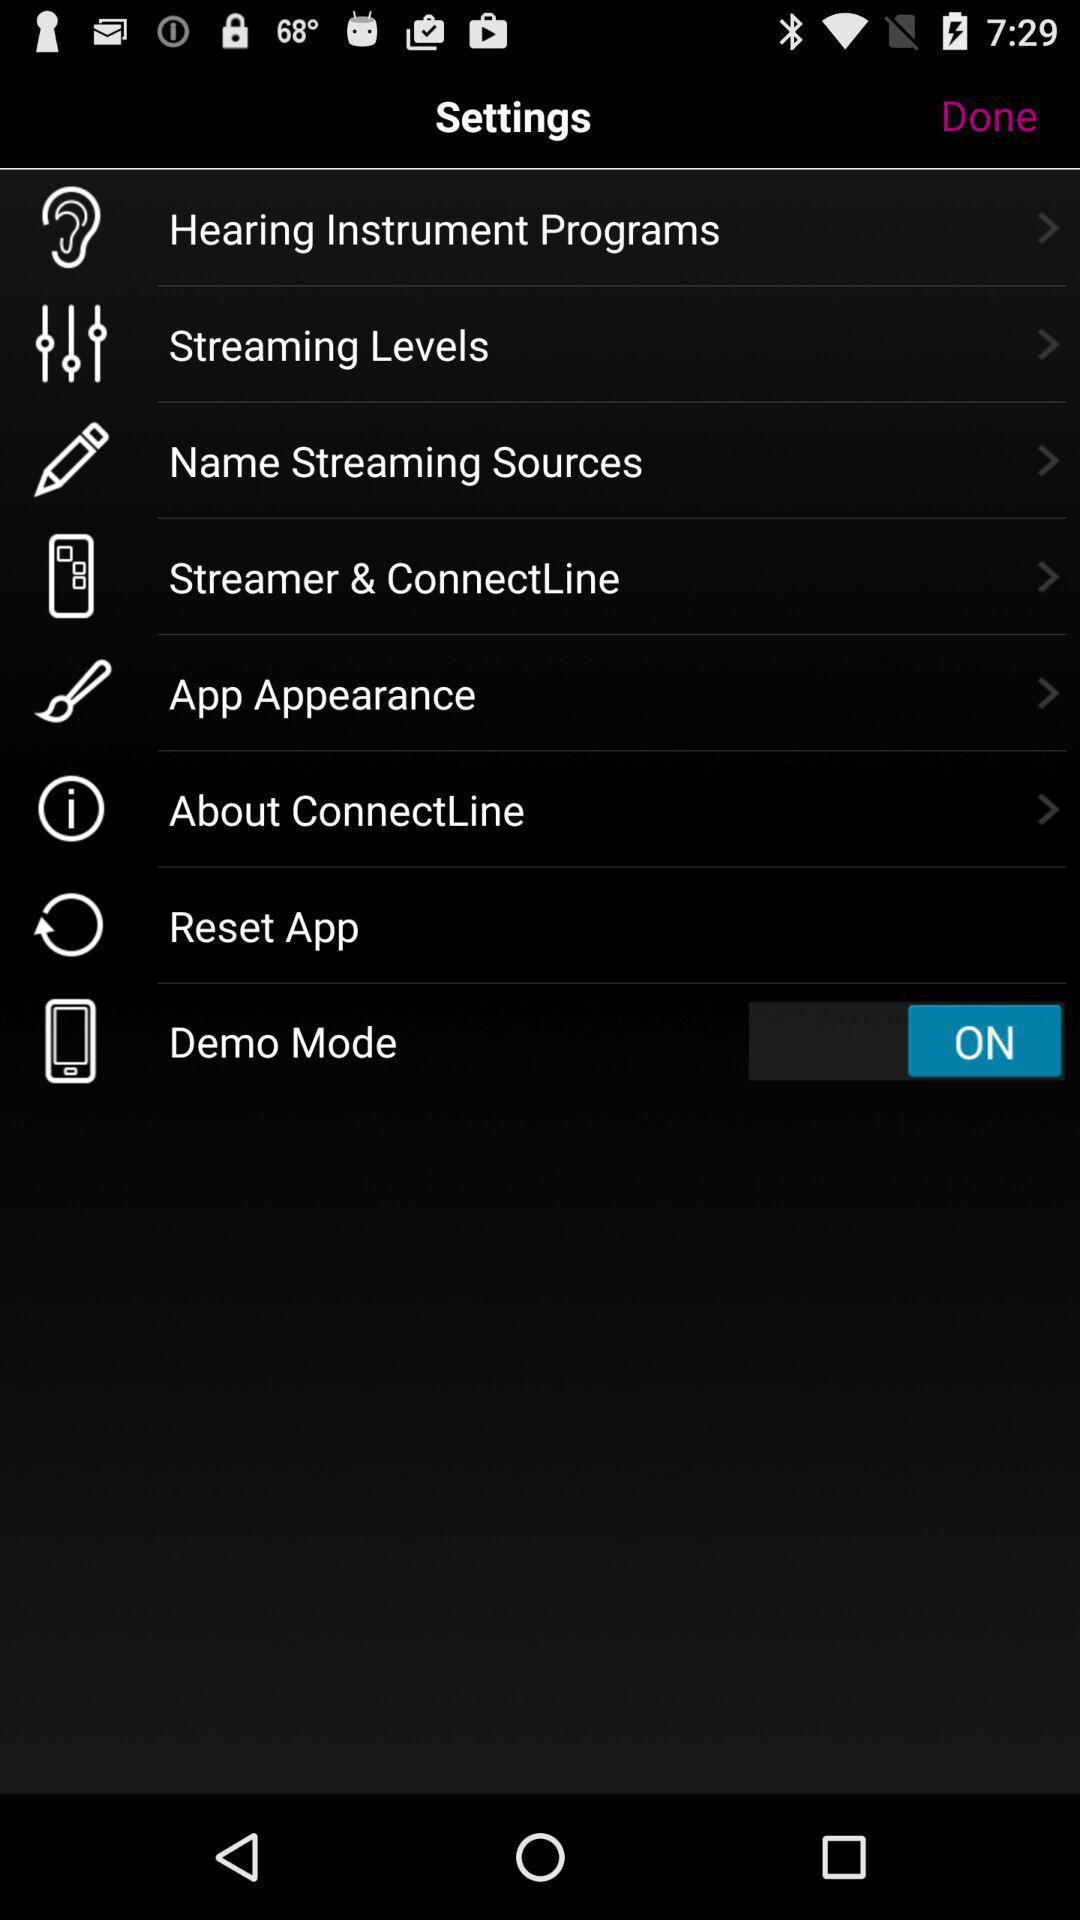What is the status of the "Demo Mode"? The status of the "Demo Mode" is "on". 